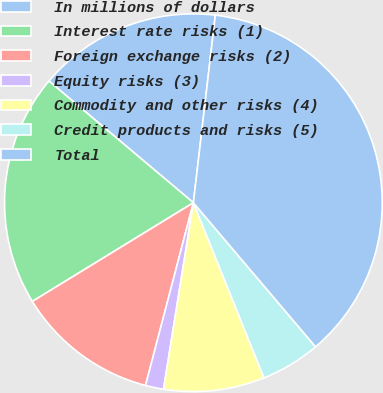Convert chart to OTSL. <chart><loc_0><loc_0><loc_500><loc_500><pie_chart><fcel>In millions of dollars<fcel>Interest rate risks (1)<fcel>Foreign exchange risks (2)<fcel>Equity risks (3)<fcel>Commodity and other risks (4)<fcel>Credit products and risks (5)<fcel>Total<nl><fcel>15.71%<fcel>19.89%<fcel>12.17%<fcel>1.55%<fcel>8.63%<fcel>5.09%<fcel>36.95%<nl></chart> 